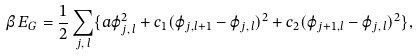Convert formula to latex. <formula><loc_0><loc_0><loc_500><loc_500>\beta \, E _ { G } = \frac { 1 } { 2 } \sum _ { j , \, l } \{ a \varphi _ { j , \, l } ^ { 2 } + c _ { 1 } ( \varphi _ { j , l + 1 } - \varphi _ { j , \, l } ) ^ { 2 } + c _ { 2 } ( \varphi _ { j + 1 , l } - \varphi _ { j , \, l } ) ^ { 2 } \} ,</formula> 